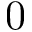<formula> <loc_0><loc_0><loc_500><loc_500>0</formula> 